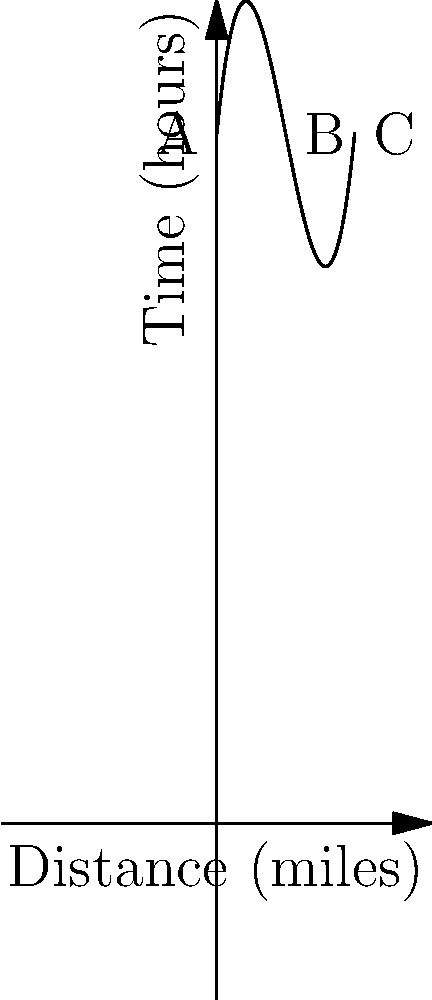As a cruise ship tour guide, you're planning a route between three Bahamian ports: A, B, and C. The time (in hours) required to travel between these ports can be modeled by the function $T(x) = 0.05x^3 - 1.5x^2 + 10x + 100$, where $x$ is the distance in miles. If the total distance between ports A and C is 20 miles, with port B located between them, at what distance from port A should port B be located to minimize the total travel time? To solve this optimization problem, we need to follow these steps:

1) The total time function for the trip from A to C via B is:
   $T_{total}(x) = T(x) + T(20-x)$, where $x$ is the distance from A to B.

2) Expanding this:
   $T_{total}(x) = [0.05x^3 - 1.5x^2 + 10x + 100] + [0.05(20-x)^3 - 1.5(20-x)^2 + 10(20-x) + 100]$

3) To find the minimum, we need to differentiate $T_{total}(x)$ with respect to $x$ and set it to zero:
   $\frac{dT_{total}}{dx} = (0.15x^2 - 3x + 10) + [-0.15(20-x)^2 + 3(20-x) - 10] = 0$

4) Simplifying:
   $0.15x^2 - 3x + 10 - 0.15(400-40x+x^2) + 60 - 3x - 10 = 0$
   $0.15x^2 - 3x + 10 - 60 + 6x - 0.15x^2 + 60 - 3x - 10 = 0$
   $6x - 6x = 0$
   $0 = 0$

5) This is true for all values of $x$, which means the function is symmetric. The minimum occurs at the midpoint between A and C.

6) Therefore, the optimal location for port B is at $x = 10$ miles from port A.
Answer: 10 miles from port A 